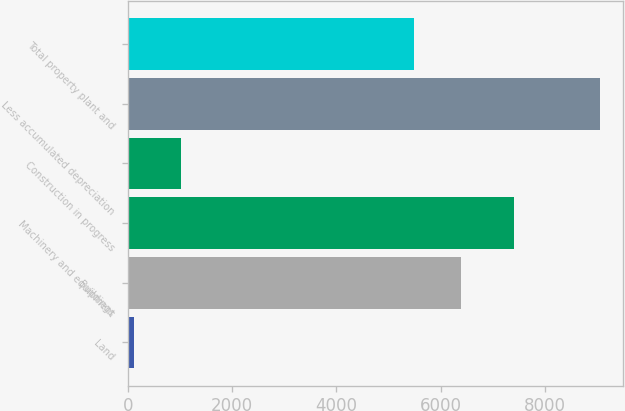Convert chart. <chart><loc_0><loc_0><loc_500><loc_500><bar_chart><fcel>Land<fcel>Buildings<fcel>Machinery and equipment<fcel>Construction in progress<fcel>Less accumulated depreciation<fcel>Total property plant and<nl><fcel>123<fcel>6383.4<fcel>7409<fcel>1016.4<fcel>9057<fcel>5490<nl></chart> 